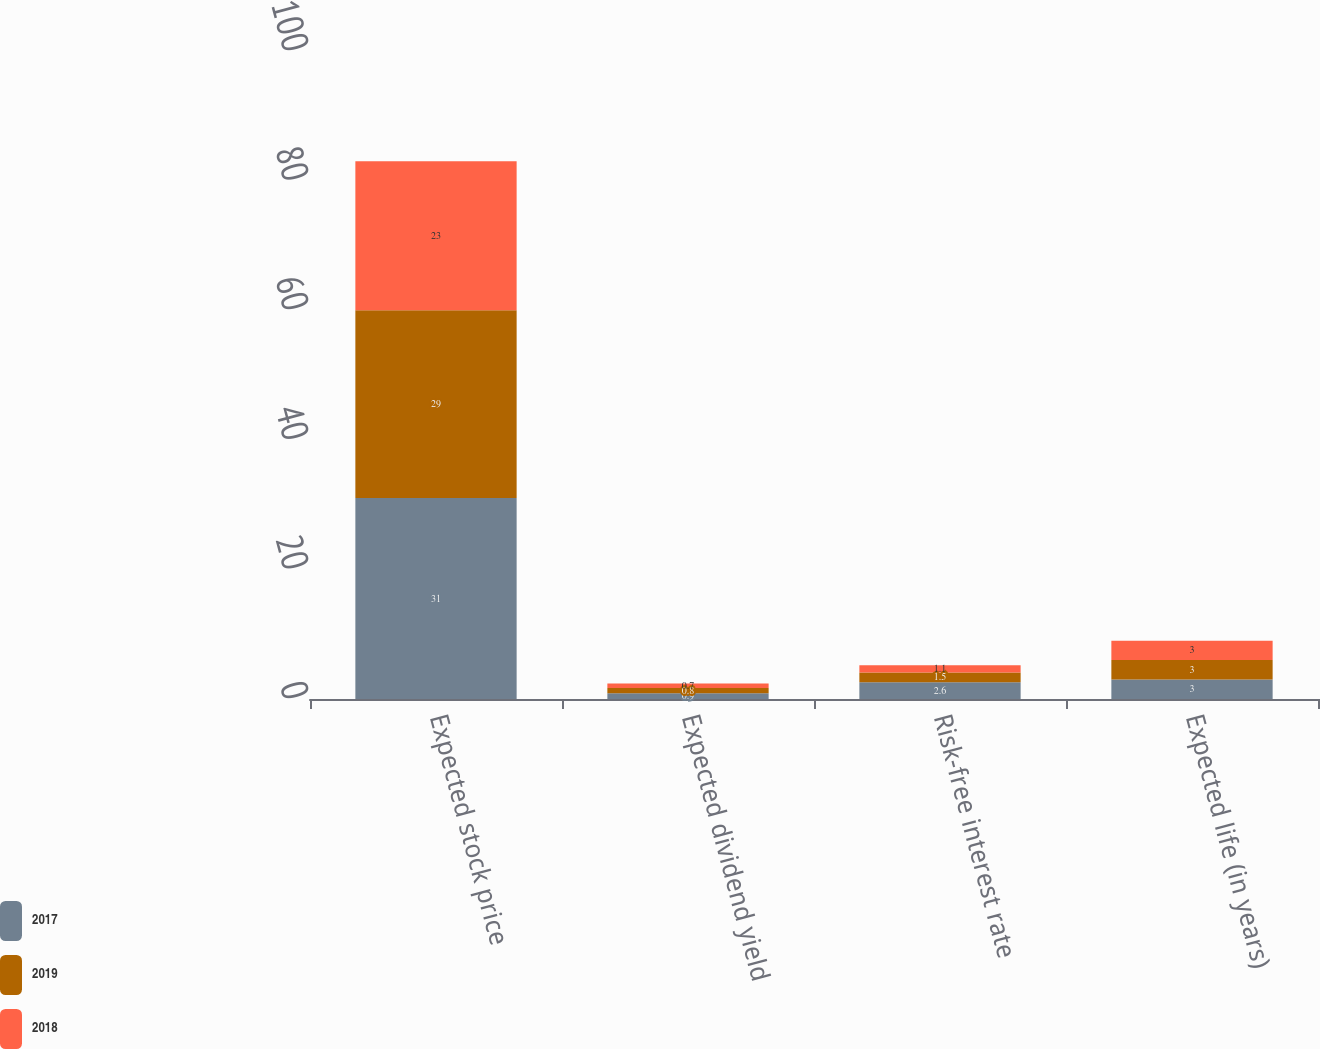Convert chart. <chart><loc_0><loc_0><loc_500><loc_500><stacked_bar_chart><ecel><fcel>Expected stock price<fcel>Expected dividend yield<fcel>Risk-free interest rate<fcel>Expected life (in years)<nl><fcel>2017<fcel>31<fcel>0.9<fcel>2.6<fcel>3<nl><fcel>2019<fcel>29<fcel>0.8<fcel>1.5<fcel>3<nl><fcel>2018<fcel>23<fcel>0.7<fcel>1.1<fcel>3<nl></chart> 